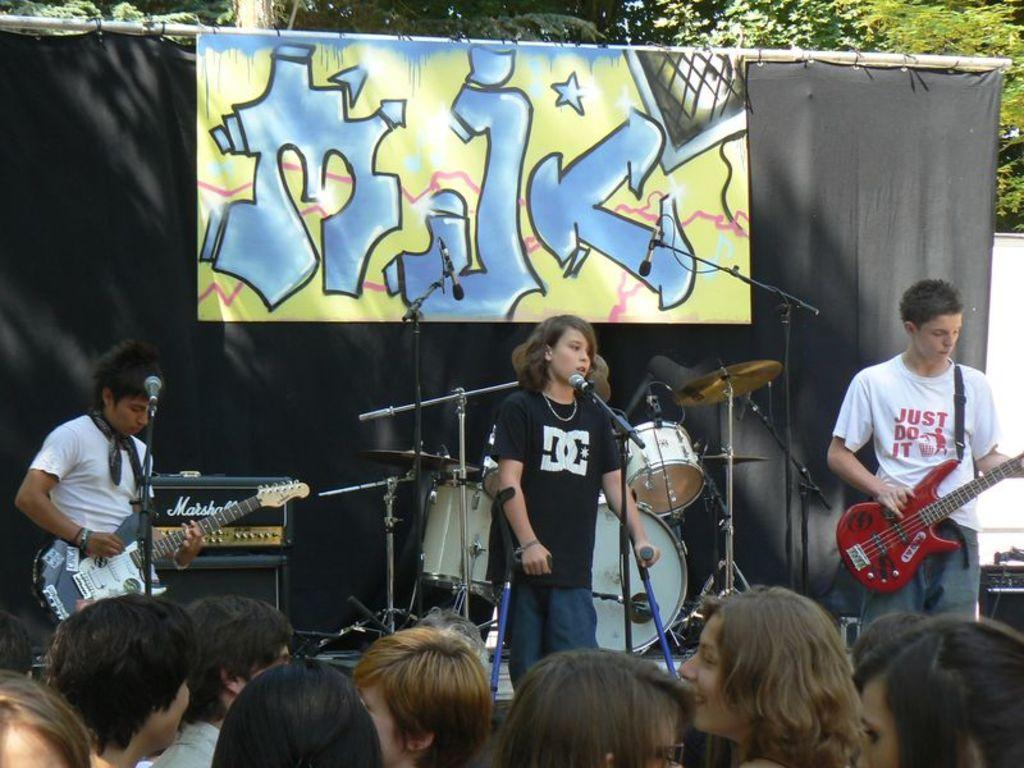What are the people in the image doing? There is a group of people playing musical instruments in the image, and another group of people is watching the performance. What can be seen in the background of the image? There is a banner and a tree in the background of the image. How many quarters are visible in the image? There are no quarters present in the image. What is the limit of the performance in the image? The image does not indicate any limit on the performance; it only shows the ongoing event. 